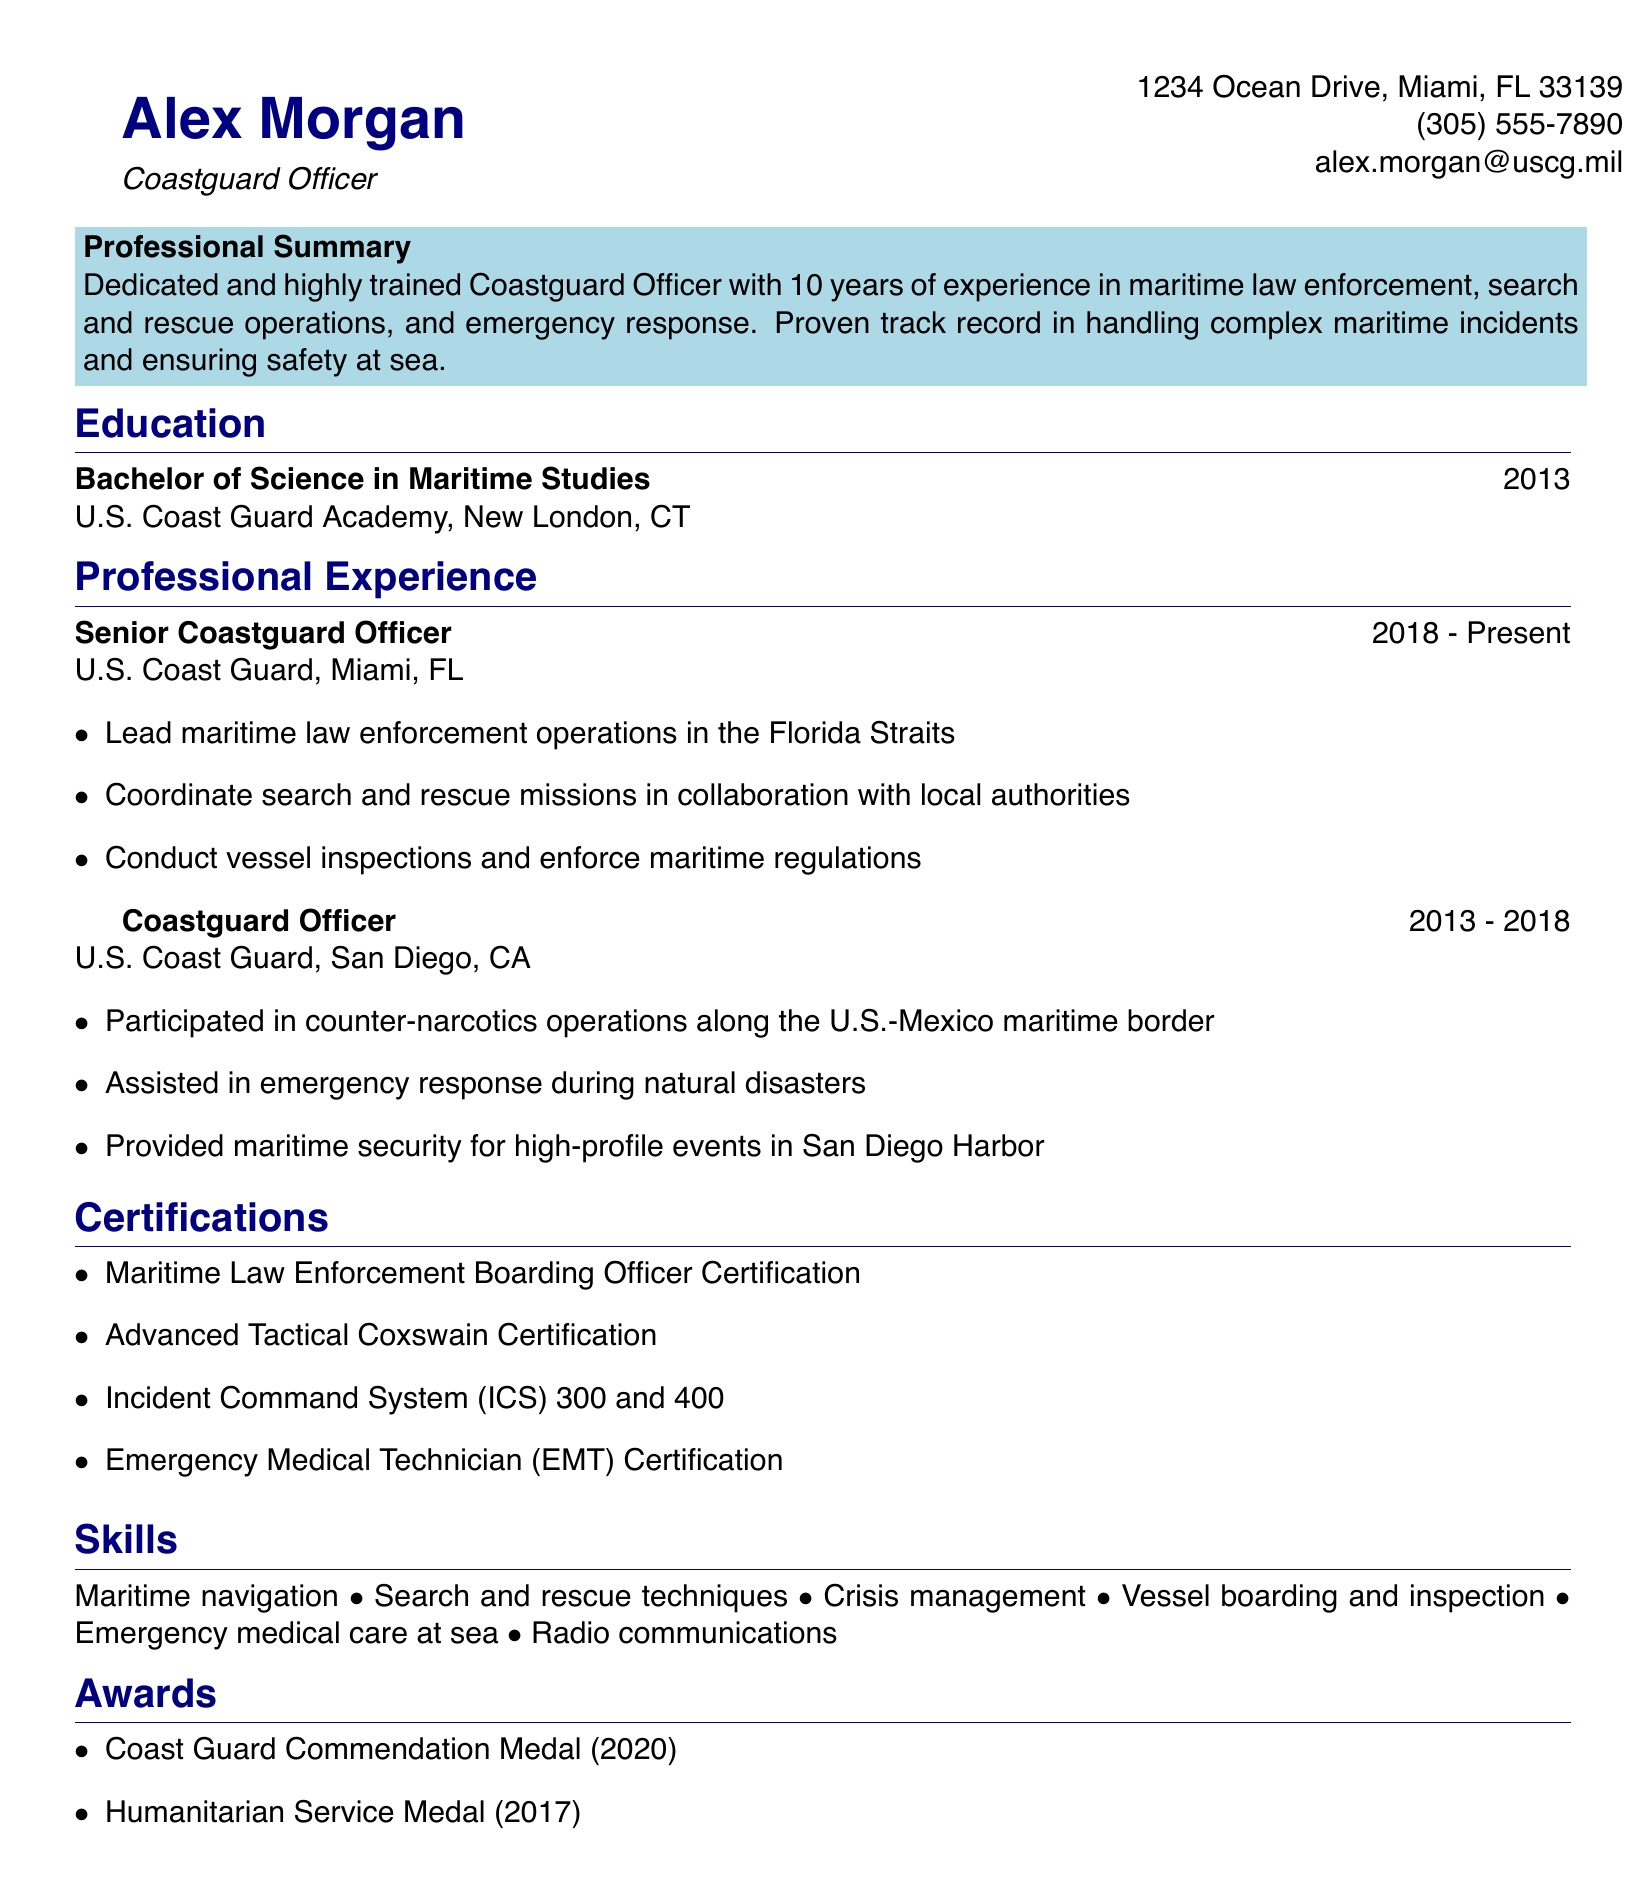What is the name of the individual? The individual's name is listed at the top of the document.
Answer: Alex Morgan What is the location of the U.S. Coast Guard Academy? The document provides the location of the institution in the education section.
Answer: New London, CT In which year did Alex Morgan graduate? The graduation year is mentioned next to the degree in the education section.
Answer: 2013 What is one of the responsibilities of the Senior Coastguard Officer? A specific responsibility is listed in the professional experience section.
Answer: Lead maritime law enforcement operations in the Florida Straits How many years of experience does Alex Morgan have? The professional summary states the amount of experience the individual possesses.
Answer: 10 years What certification is related to maritime law enforcement? The certifications section lists specific qualifications relevant to maritime law enforcement.
Answer: Maritime Law Enforcement Boarding Officer Certification Which medal did Alex Morgan receive in 2020? The award section notes the specific recognition received in that year.
Answer: Coast Guard Commendation Medal What type of degree does Alex Morgan hold? The education section specifies the type of degree attained.
Answer: Bachelor of Science in Maritime Studies What is one skill mentioned in the CV? The skills section lists various competencies.
Answer: Maritime navigation 